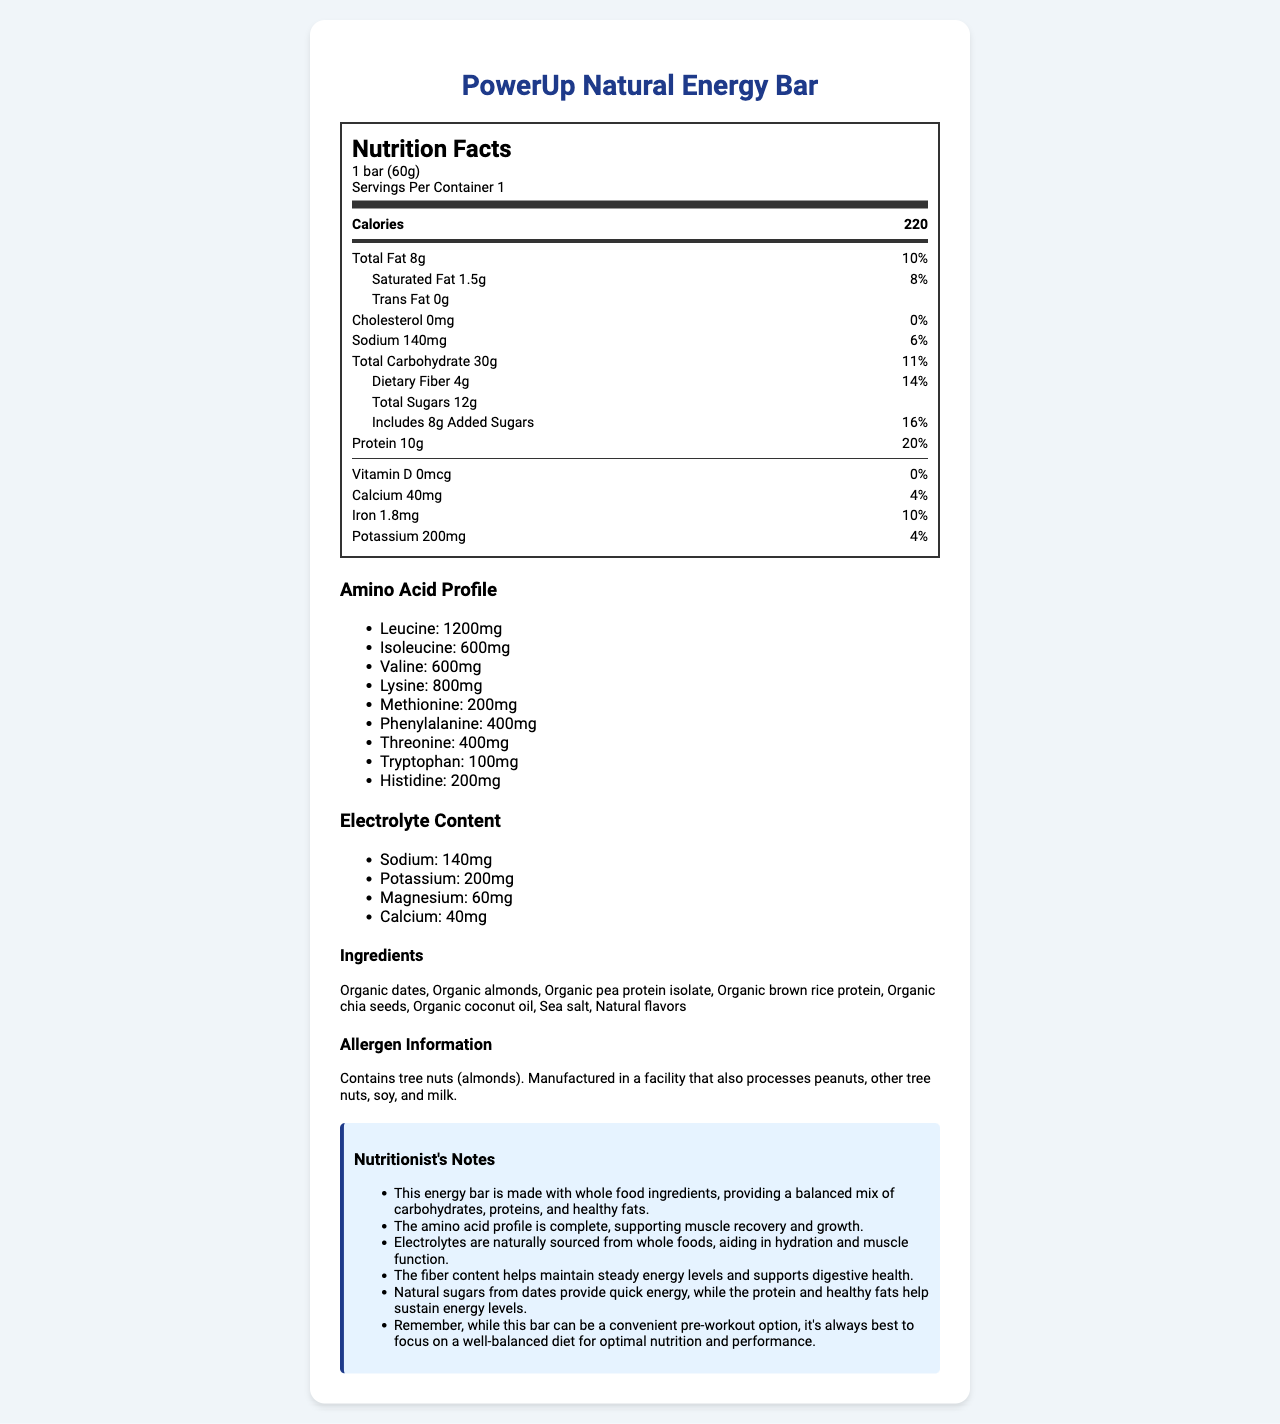what is the serving size? The serving size is mentioned at the top of the nutrition label under the "Nutrition Facts" section.
Answer: 1 bar (60g) how many calories does one bar contain? The calorie content is highlighted in bold under "Nutrition Facts."
Answer: 220 what are the three primary sources of protein in the ingredients list? These ingredients are listed among the components of the "PowerUp Natural Energy Bar."
Answer: Organic pea protein isolate, Organic brown rice protein, Organic chia seeds how much dietary fiber is in one serving? The dietary fiber content is listed under the "Total Carbohydrate" section.
Answer: 4g what is the total amount of fat and its daily value percentage? The total fat is given as 8g with a daily value percentage of 10%.
Answer: 8g, 10% what amino acid is present in the highest amount? A. Leucine B. Lysine C. Methionine The amino acid profile shows that leucine is present in the highest amount (1200mg).
Answer: A. Leucine which nutrient does not contribute any percentage to the daily value? 1. Vitamin D 2. Calcium 3. Iron 4. Potassium The nutrition label lists the daily value percentage for Vitamin D as 0%.
Answer: 1. Vitamin D Is this energy bar a good source of potassium? The bar contains 200mg of potassium, which is 4% of the daily value, indicating it contributes to the daily potassium intake.
Answer: Yes describe the main idea of the document. The document offers detailed nutritional information about the energy bar, helping users understand its health benefits and nutritional composition.
Answer: The document provides a comprehensive nutrition facts label for the "PowerUp Natural Energy Bar", featuring details such as serving size, calorie count, fat, carbohydrate, and protein content, along with a breakdown of its amino acid profile and electrolyte content. The label also includes an ingredients list, allergen information, and nutritionist notes highlighting the bar's benefits for muscle recovery, sustained energy, and digestive health. what is the source of the added sugars in this energy bar? The document specifies there are 8g of added sugars but does not provide information on the source of these sugars.
Answer: Cannot be determined how much sodium is in the energy bar? Sodium content is listed in the nutrition facts section.
Answer: 140mg what are the two main types of protein sources listed in the ingredients? A. Whey protein and egg whites B. Pea protein and brown rice protein C. Soy protein and hemp protein The ingredients list shows that the main protein sources are organic pea protein isolate and organic brown rice protein.
Answer: B. Pea protein and brown rice protein does the energy bar contain any artificial flavors or colors? The ingredients list features natural ingredients and specifies "Natural flavors" without mentioning any artificial additives.
Answer: No is the energy bar suitable for people with peanut allergies? The allergen information mentions that the bar is manufactured in a facility that also processes peanuts.
Answer: No 